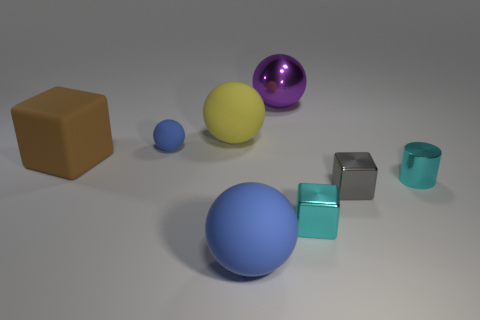There is a shiny thing that is the same color as the tiny metallic cylinder; what is its shape?
Your response must be concise. Cube. There is a metallic cylinder; is its color the same as the small cube in front of the tiny gray metal block?
Offer a terse response. Yes. The block on the left side of the blue matte sphere that is in front of the cube left of the big metallic ball is what color?
Give a very brief answer. Brown. Is there a cyan metallic object that has the same shape as the tiny blue rubber thing?
Give a very brief answer. No. What color is the matte cube that is the same size as the purple metal object?
Your response must be concise. Brown. What is the material of the brown block that is left of the yellow matte thing?
Your answer should be very brief. Rubber. There is a tiny thing that is behind the brown cube; is its shape the same as the tiny metallic thing behind the gray block?
Keep it short and to the point. No. Is the number of small things on the right side of the cyan cube the same as the number of big matte spheres?
Make the answer very short. Yes. What number of brown cubes are the same material as the big brown thing?
Provide a short and direct response. 0. There is a tiny ball that is the same material as the large brown object; what is its color?
Offer a very short reply. Blue. 